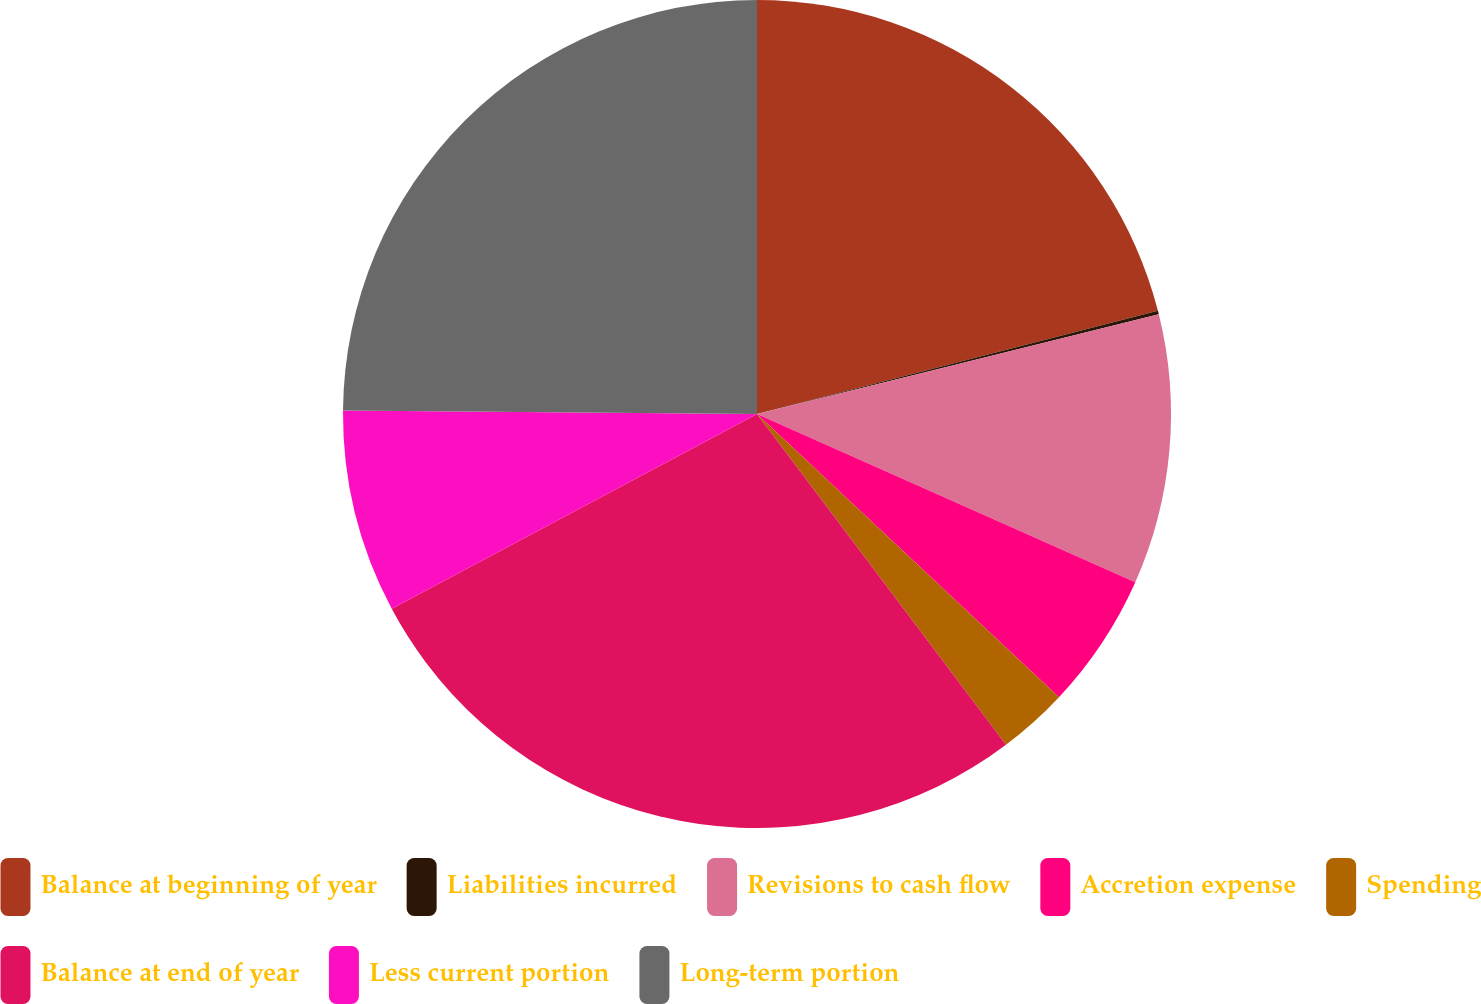<chart> <loc_0><loc_0><loc_500><loc_500><pie_chart><fcel>Balance at beginning of year<fcel>Liabilities incurred<fcel>Revisions to cash flow<fcel>Accretion expense<fcel>Spending<fcel>Balance at end of year<fcel>Less current portion<fcel>Long-term portion<nl><fcel>20.99%<fcel>0.14%<fcel>10.53%<fcel>5.33%<fcel>2.74%<fcel>27.47%<fcel>7.93%<fcel>24.87%<nl></chart> 